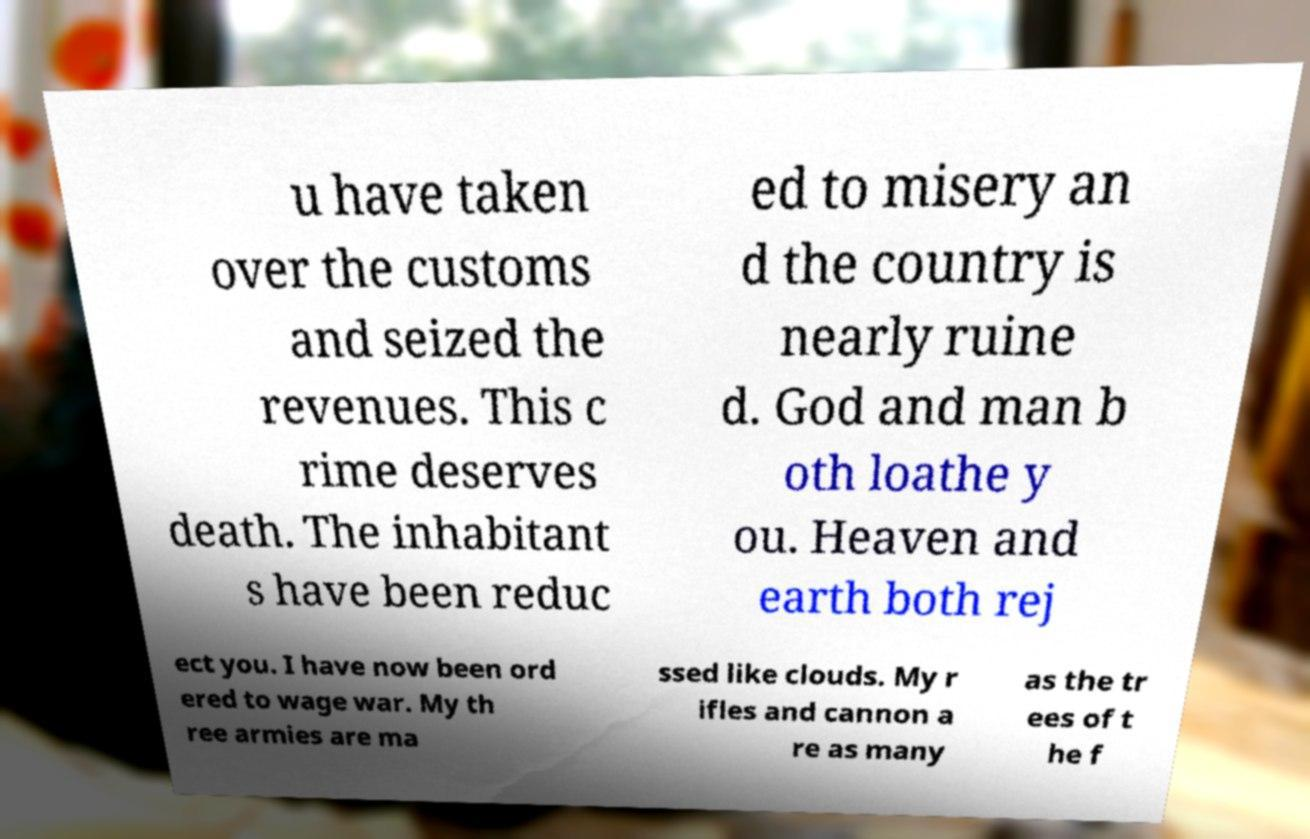Could you assist in decoding the text presented in this image and type it out clearly? u have taken over the customs and seized the revenues. This c rime deserves death. The inhabitant s have been reduc ed to misery an d the country is nearly ruine d. God and man b oth loathe y ou. Heaven and earth both rej ect you. I have now been ord ered to wage war. My th ree armies are ma ssed like clouds. My r ifles and cannon a re as many as the tr ees of t he f 